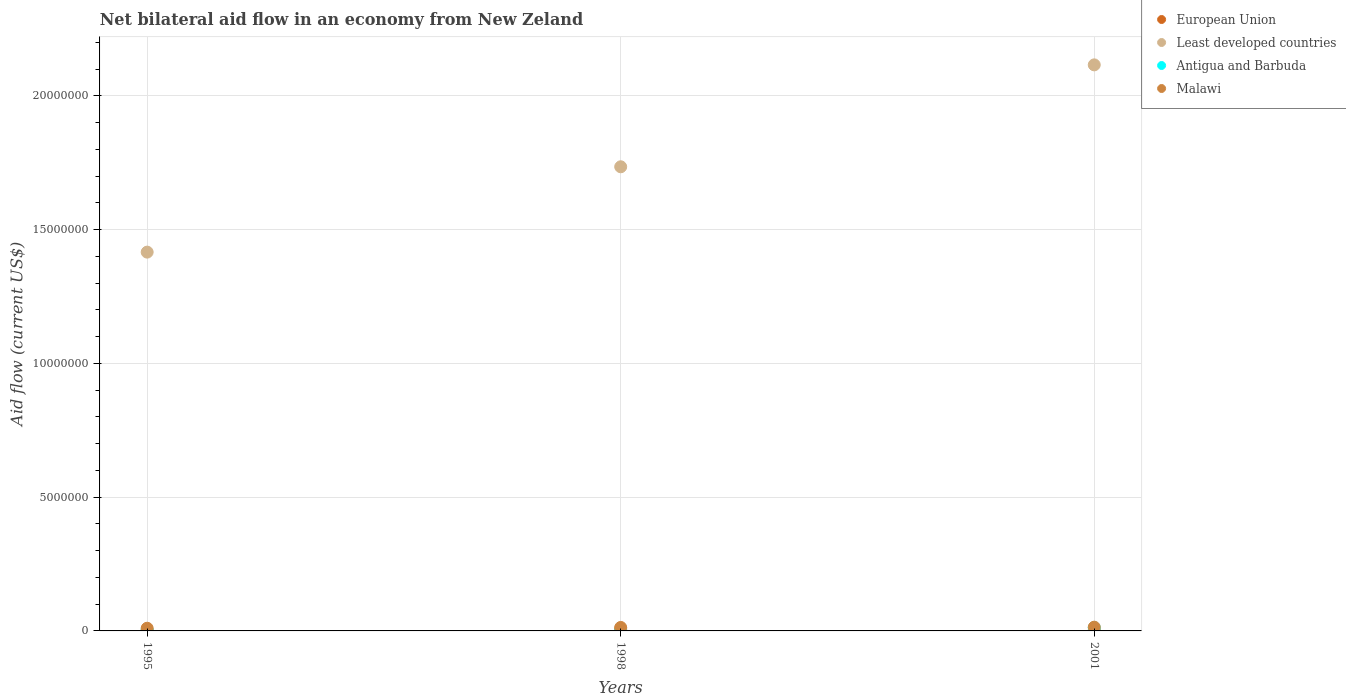What is the net bilateral aid flow in Least developed countries in 1995?
Your response must be concise. 1.42e+07. Across all years, what is the maximum net bilateral aid flow in Antigua and Barbuda?
Ensure brevity in your answer.  1.20e+05. Across all years, what is the minimum net bilateral aid flow in Least developed countries?
Keep it short and to the point. 1.42e+07. In which year was the net bilateral aid flow in Antigua and Barbuda maximum?
Make the answer very short. 2001. In which year was the net bilateral aid flow in European Union minimum?
Offer a terse response. 1995. What is the total net bilateral aid flow in Least developed countries in the graph?
Ensure brevity in your answer.  5.27e+07. What is the difference between the net bilateral aid flow in Antigua and Barbuda in 1998 and that in 2001?
Offer a very short reply. -1.10e+05. What is the difference between the net bilateral aid flow in European Union in 1998 and the net bilateral aid flow in Malawi in 1995?
Keep it short and to the point. -3.00e+04. What is the average net bilateral aid flow in Antigua and Barbuda per year?
Give a very brief answer. 5.33e+04. In the year 1998, what is the difference between the net bilateral aid flow in Least developed countries and net bilateral aid flow in European Union?
Your response must be concise. 1.73e+07. What is the ratio of the net bilateral aid flow in Malawi in 1998 to that in 2001?
Keep it short and to the point. 0.93. Is the net bilateral aid flow in Antigua and Barbuda in 1995 less than that in 1998?
Make the answer very short. No. What is the difference between the highest and the lowest net bilateral aid flow in Malawi?
Provide a short and direct response. 4.00e+04. In how many years, is the net bilateral aid flow in Malawi greater than the average net bilateral aid flow in Malawi taken over all years?
Provide a short and direct response. 2. Is the sum of the net bilateral aid flow in Malawi in 1995 and 2001 greater than the maximum net bilateral aid flow in Antigua and Barbuda across all years?
Your response must be concise. Yes. Is it the case that in every year, the sum of the net bilateral aid flow in Antigua and Barbuda and net bilateral aid flow in Malawi  is greater than the sum of net bilateral aid flow in Least developed countries and net bilateral aid flow in European Union?
Give a very brief answer. Yes. Is the net bilateral aid flow in Least developed countries strictly greater than the net bilateral aid flow in Malawi over the years?
Give a very brief answer. Yes. Is the net bilateral aid flow in Malawi strictly less than the net bilateral aid flow in European Union over the years?
Ensure brevity in your answer.  No. How many dotlines are there?
Your answer should be compact. 4. How many years are there in the graph?
Provide a succinct answer. 3. Are the values on the major ticks of Y-axis written in scientific E-notation?
Keep it short and to the point. No. How many legend labels are there?
Make the answer very short. 4. What is the title of the graph?
Your response must be concise. Net bilateral aid flow in an economy from New Zeland. Does "Cuba" appear as one of the legend labels in the graph?
Provide a succinct answer. No. What is the label or title of the X-axis?
Keep it short and to the point. Years. What is the Aid flow (current US$) in European Union in 1995?
Your response must be concise. 2.00e+04. What is the Aid flow (current US$) of Least developed countries in 1995?
Your answer should be very brief. 1.42e+07. What is the Aid flow (current US$) of Least developed countries in 1998?
Your response must be concise. 1.74e+07. What is the Aid flow (current US$) in Antigua and Barbuda in 1998?
Ensure brevity in your answer.  10000. What is the Aid flow (current US$) in Least developed countries in 2001?
Offer a very short reply. 2.12e+07. What is the Aid flow (current US$) of Malawi in 2001?
Your answer should be very brief. 1.40e+05. Across all years, what is the maximum Aid flow (current US$) in European Union?
Provide a succinct answer. 7.00e+04. Across all years, what is the maximum Aid flow (current US$) in Least developed countries?
Ensure brevity in your answer.  2.12e+07. Across all years, what is the maximum Aid flow (current US$) of Antigua and Barbuda?
Your answer should be compact. 1.20e+05. Across all years, what is the minimum Aid flow (current US$) of Least developed countries?
Your answer should be compact. 1.42e+07. Across all years, what is the minimum Aid flow (current US$) of Antigua and Barbuda?
Offer a terse response. 10000. Across all years, what is the minimum Aid flow (current US$) of Malawi?
Your response must be concise. 1.00e+05. What is the total Aid flow (current US$) of European Union in the graph?
Ensure brevity in your answer.  1.10e+05. What is the total Aid flow (current US$) of Least developed countries in the graph?
Provide a short and direct response. 5.27e+07. What is the total Aid flow (current US$) in Antigua and Barbuda in the graph?
Keep it short and to the point. 1.60e+05. What is the total Aid flow (current US$) of Malawi in the graph?
Ensure brevity in your answer.  3.70e+05. What is the difference between the Aid flow (current US$) of Least developed countries in 1995 and that in 1998?
Make the answer very short. -3.19e+06. What is the difference between the Aid flow (current US$) in Antigua and Barbuda in 1995 and that in 1998?
Your response must be concise. 2.00e+04. What is the difference between the Aid flow (current US$) of Malawi in 1995 and that in 1998?
Your answer should be very brief. -3.00e+04. What is the difference between the Aid flow (current US$) of European Union in 1995 and that in 2001?
Provide a short and direct response. 0. What is the difference between the Aid flow (current US$) in Least developed countries in 1995 and that in 2001?
Provide a succinct answer. -7.00e+06. What is the difference between the Aid flow (current US$) in Antigua and Barbuda in 1995 and that in 2001?
Your response must be concise. -9.00e+04. What is the difference between the Aid flow (current US$) in Least developed countries in 1998 and that in 2001?
Your response must be concise. -3.81e+06. What is the difference between the Aid flow (current US$) of Antigua and Barbuda in 1998 and that in 2001?
Your answer should be very brief. -1.10e+05. What is the difference between the Aid flow (current US$) in Malawi in 1998 and that in 2001?
Your answer should be very brief. -10000. What is the difference between the Aid flow (current US$) of European Union in 1995 and the Aid flow (current US$) of Least developed countries in 1998?
Offer a very short reply. -1.73e+07. What is the difference between the Aid flow (current US$) in European Union in 1995 and the Aid flow (current US$) in Antigua and Barbuda in 1998?
Provide a short and direct response. 10000. What is the difference between the Aid flow (current US$) of European Union in 1995 and the Aid flow (current US$) of Malawi in 1998?
Make the answer very short. -1.10e+05. What is the difference between the Aid flow (current US$) in Least developed countries in 1995 and the Aid flow (current US$) in Antigua and Barbuda in 1998?
Keep it short and to the point. 1.42e+07. What is the difference between the Aid flow (current US$) of Least developed countries in 1995 and the Aid flow (current US$) of Malawi in 1998?
Ensure brevity in your answer.  1.40e+07. What is the difference between the Aid flow (current US$) in European Union in 1995 and the Aid flow (current US$) in Least developed countries in 2001?
Your response must be concise. -2.11e+07. What is the difference between the Aid flow (current US$) in European Union in 1995 and the Aid flow (current US$) in Antigua and Barbuda in 2001?
Offer a very short reply. -1.00e+05. What is the difference between the Aid flow (current US$) of European Union in 1995 and the Aid flow (current US$) of Malawi in 2001?
Provide a succinct answer. -1.20e+05. What is the difference between the Aid flow (current US$) in Least developed countries in 1995 and the Aid flow (current US$) in Antigua and Barbuda in 2001?
Keep it short and to the point. 1.40e+07. What is the difference between the Aid flow (current US$) of Least developed countries in 1995 and the Aid flow (current US$) of Malawi in 2001?
Make the answer very short. 1.40e+07. What is the difference between the Aid flow (current US$) of European Union in 1998 and the Aid flow (current US$) of Least developed countries in 2001?
Ensure brevity in your answer.  -2.11e+07. What is the difference between the Aid flow (current US$) of European Union in 1998 and the Aid flow (current US$) of Antigua and Barbuda in 2001?
Your response must be concise. -5.00e+04. What is the difference between the Aid flow (current US$) of Least developed countries in 1998 and the Aid flow (current US$) of Antigua and Barbuda in 2001?
Provide a short and direct response. 1.72e+07. What is the difference between the Aid flow (current US$) of Least developed countries in 1998 and the Aid flow (current US$) of Malawi in 2001?
Provide a short and direct response. 1.72e+07. What is the difference between the Aid flow (current US$) of Antigua and Barbuda in 1998 and the Aid flow (current US$) of Malawi in 2001?
Provide a short and direct response. -1.30e+05. What is the average Aid flow (current US$) of European Union per year?
Give a very brief answer. 3.67e+04. What is the average Aid flow (current US$) of Least developed countries per year?
Your response must be concise. 1.76e+07. What is the average Aid flow (current US$) in Antigua and Barbuda per year?
Ensure brevity in your answer.  5.33e+04. What is the average Aid flow (current US$) in Malawi per year?
Offer a terse response. 1.23e+05. In the year 1995, what is the difference between the Aid flow (current US$) of European Union and Aid flow (current US$) of Least developed countries?
Provide a short and direct response. -1.41e+07. In the year 1995, what is the difference between the Aid flow (current US$) in European Union and Aid flow (current US$) in Malawi?
Offer a very short reply. -8.00e+04. In the year 1995, what is the difference between the Aid flow (current US$) in Least developed countries and Aid flow (current US$) in Antigua and Barbuda?
Provide a succinct answer. 1.41e+07. In the year 1995, what is the difference between the Aid flow (current US$) of Least developed countries and Aid flow (current US$) of Malawi?
Make the answer very short. 1.41e+07. In the year 1995, what is the difference between the Aid flow (current US$) of Antigua and Barbuda and Aid flow (current US$) of Malawi?
Make the answer very short. -7.00e+04. In the year 1998, what is the difference between the Aid flow (current US$) in European Union and Aid flow (current US$) in Least developed countries?
Keep it short and to the point. -1.73e+07. In the year 1998, what is the difference between the Aid flow (current US$) in European Union and Aid flow (current US$) in Antigua and Barbuda?
Provide a short and direct response. 6.00e+04. In the year 1998, what is the difference between the Aid flow (current US$) in Least developed countries and Aid flow (current US$) in Antigua and Barbuda?
Your answer should be very brief. 1.73e+07. In the year 1998, what is the difference between the Aid flow (current US$) in Least developed countries and Aid flow (current US$) in Malawi?
Offer a very short reply. 1.72e+07. In the year 2001, what is the difference between the Aid flow (current US$) of European Union and Aid flow (current US$) of Least developed countries?
Give a very brief answer. -2.11e+07. In the year 2001, what is the difference between the Aid flow (current US$) in European Union and Aid flow (current US$) in Antigua and Barbuda?
Your answer should be very brief. -1.00e+05. In the year 2001, what is the difference between the Aid flow (current US$) in European Union and Aid flow (current US$) in Malawi?
Ensure brevity in your answer.  -1.20e+05. In the year 2001, what is the difference between the Aid flow (current US$) of Least developed countries and Aid flow (current US$) of Antigua and Barbuda?
Provide a short and direct response. 2.10e+07. In the year 2001, what is the difference between the Aid flow (current US$) of Least developed countries and Aid flow (current US$) of Malawi?
Offer a very short reply. 2.10e+07. What is the ratio of the Aid flow (current US$) in European Union in 1995 to that in 1998?
Provide a succinct answer. 0.29. What is the ratio of the Aid flow (current US$) of Least developed countries in 1995 to that in 1998?
Offer a very short reply. 0.82. What is the ratio of the Aid flow (current US$) in Antigua and Barbuda in 1995 to that in 1998?
Make the answer very short. 3. What is the ratio of the Aid flow (current US$) in Malawi in 1995 to that in 1998?
Your answer should be very brief. 0.77. What is the ratio of the Aid flow (current US$) of European Union in 1995 to that in 2001?
Offer a terse response. 1. What is the ratio of the Aid flow (current US$) of Least developed countries in 1995 to that in 2001?
Offer a very short reply. 0.67. What is the ratio of the Aid flow (current US$) in European Union in 1998 to that in 2001?
Your answer should be compact. 3.5. What is the ratio of the Aid flow (current US$) of Least developed countries in 1998 to that in 2001?
Provide a short and direct response. 0.82. What is the ratio of the Aid flow (current US$) of Antigua and Barbuda in 1998 to that in 2001?
Keep it short and to the point. 0.08. What is the difference between the highest and the second highest Aid flow (current US$) of Least developed countries?
Provide a short and direct response. 3.81e+06. What is the difference between the highest and the second highest Aid flow (current US$) in Antigua and Barbuda?
Keep it short and to the point. 9.00e+04. What is the difference between the highest and the second highest Aid flow (current US$) of Malawi?
Offer a terse response. 10000. What is the difference between the highest and the lowest Aid flow (current US$) of European Union?
Provide a short and direct response. 5.00e+04. What is the difference between the highest and the lowest Aid flow (current US$) in Malawi?
Ensure brevity in your answer.  4.00e+04. 